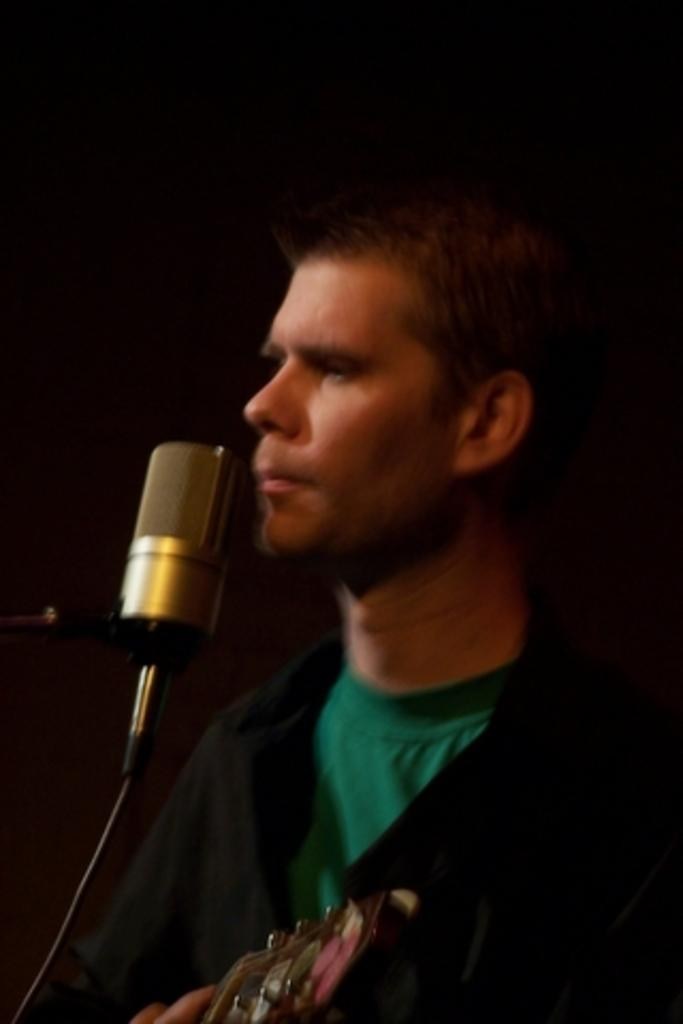What is the main subject of the image? There is a person in the image. What is the person holding in the image? The person is holding a musical instrument. What device is in front of the person? There is a microphone (mic) in front of the person. What is the color of the background in the image? The background of the image is black in color. How many cherries are on the person's dress in the image? There is no dress or cherries present in the image. What type of scale is used to weigh the musical instrument in the image? There is no scale present in the image, and the musical instrument is being held by the person, not weighed. 